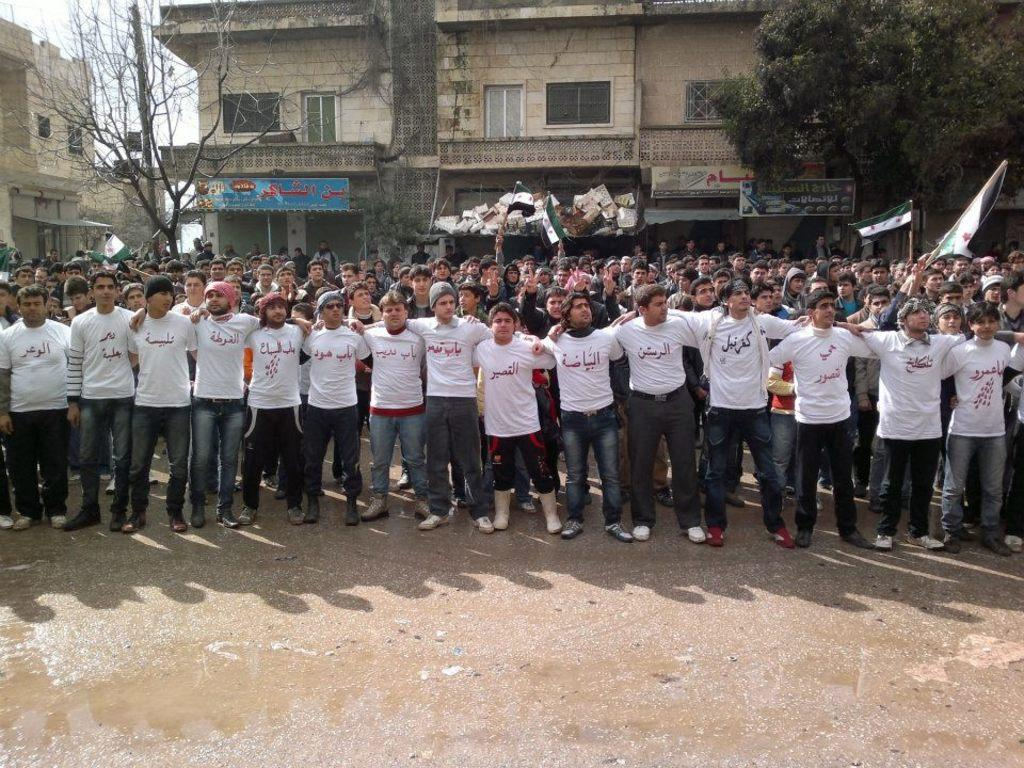How many people are in the image? There is a group of people in the image, but the exact number is not specified. What are the people doing in the image? The people are standing on a path in the image. What are some people holding in the image? Some people are holding sticks with flags in the image. What can be seen in the background of the image? There are trees, buildings, and the sky visible in the background of the image. Is there any quicksand on the path where the people are standing? There is no mention of quicksand in the image, and it is not visible in the path where the people are standing. What type of rose can be seen in the image? There is no rose present in the image. 